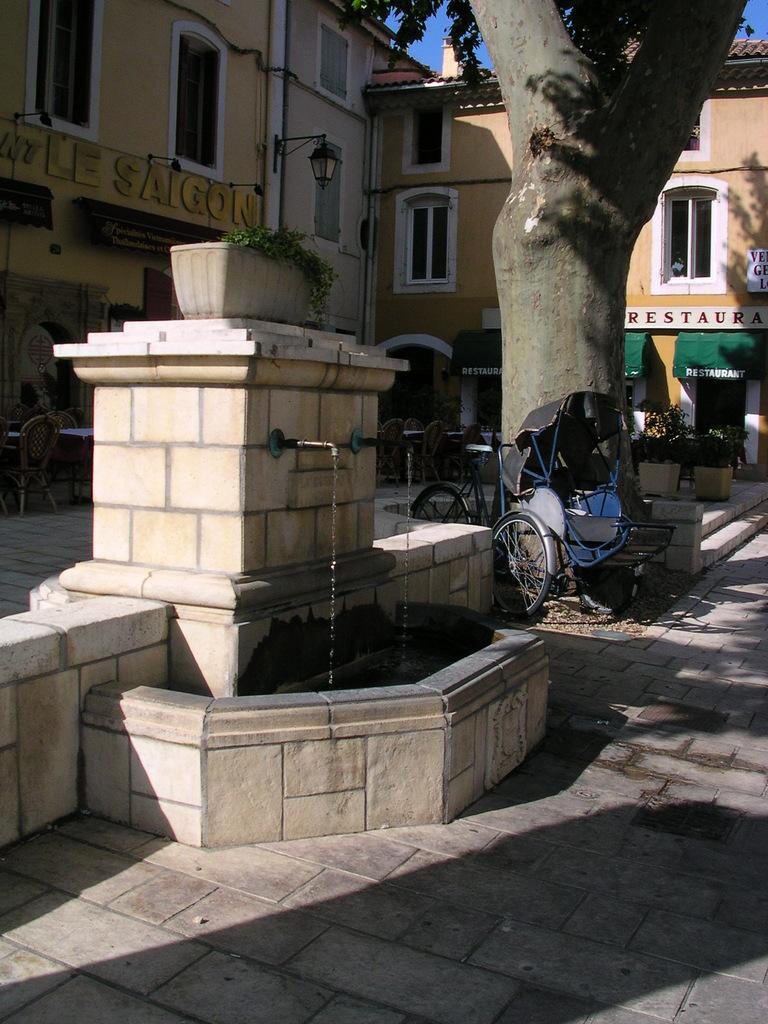Please provide a concise description of this image. In this image I can see a wall which is made of bricks, few taps to the wall and water coming out of them. I can see a bicycle and a tree. In the background I can see few buildings, few windows of the buildings, a chair, a table, few flower pots and the sky. 